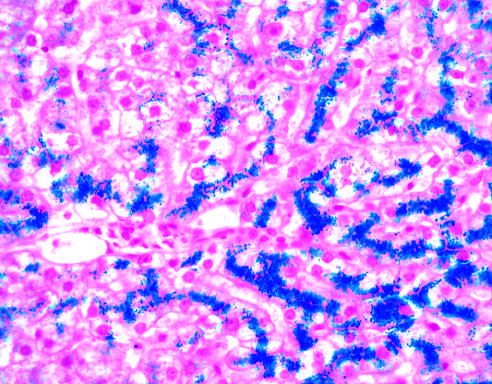where does hepatocellular iron appear blue?
Answer the question using a single word or phrase. In the prussian blue-stained section 